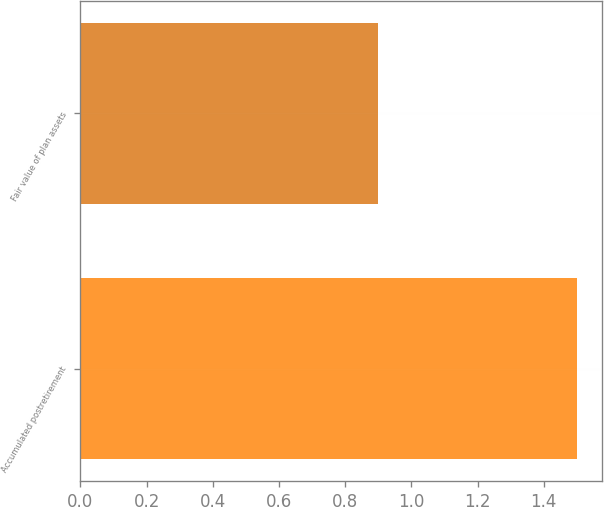<chart> <loc_0><loc_0><loc_500><loc_500><bar_chart><fcel>Accumulated postretirement<fcel>Fair value of plan assets<nl><fcel>1.5<fcel>0.9<nl></chart> 